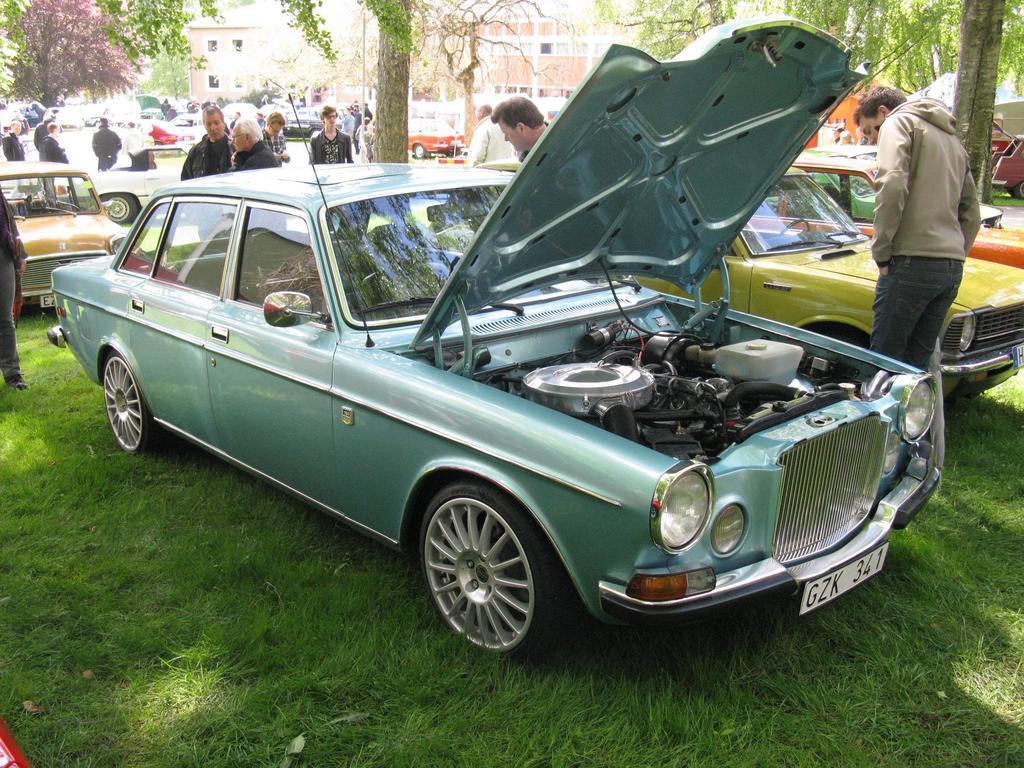In one or two sentences, can you explain what this image depicts? In this image I see number of cars and I see number of people and I see the grass. In the background I see number of trees and I see the buildings. 